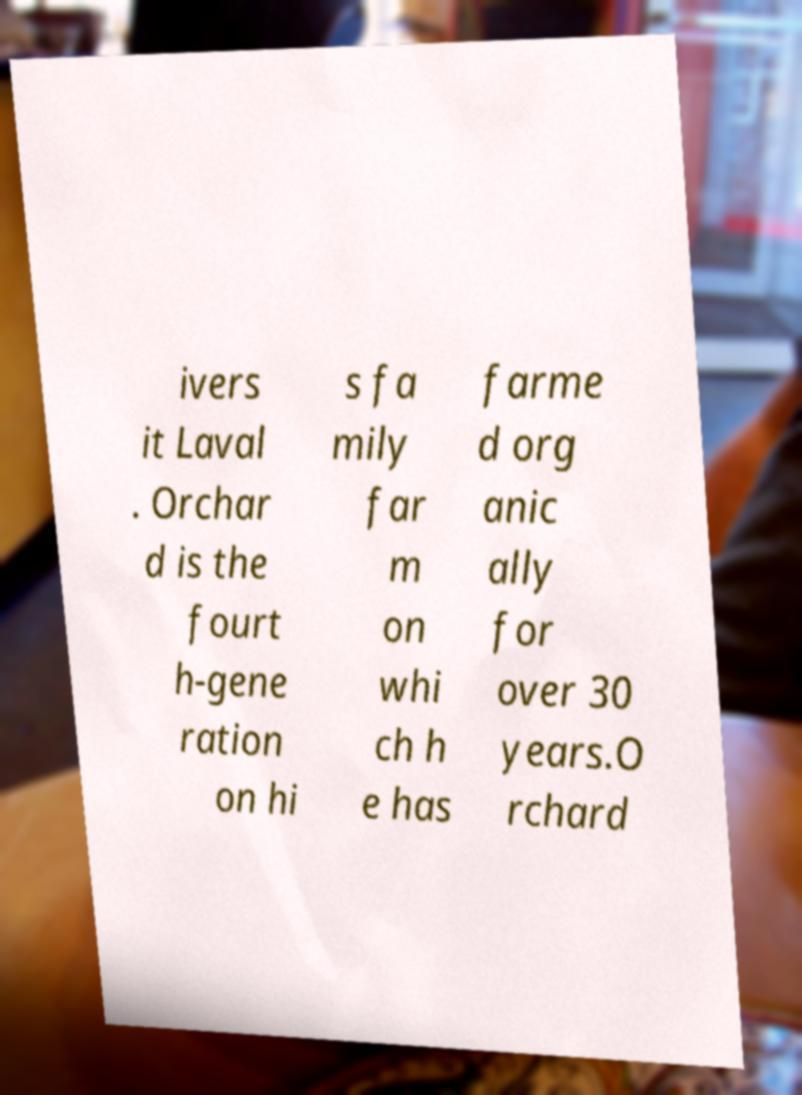Please read and relay the text visible in this image. What does it say? ivers it Laval . Orchar d is the fourt h-gene ration on hi s fa mily far m on whi ch h e has farme d org anic ally for over 30 years.O rchard 